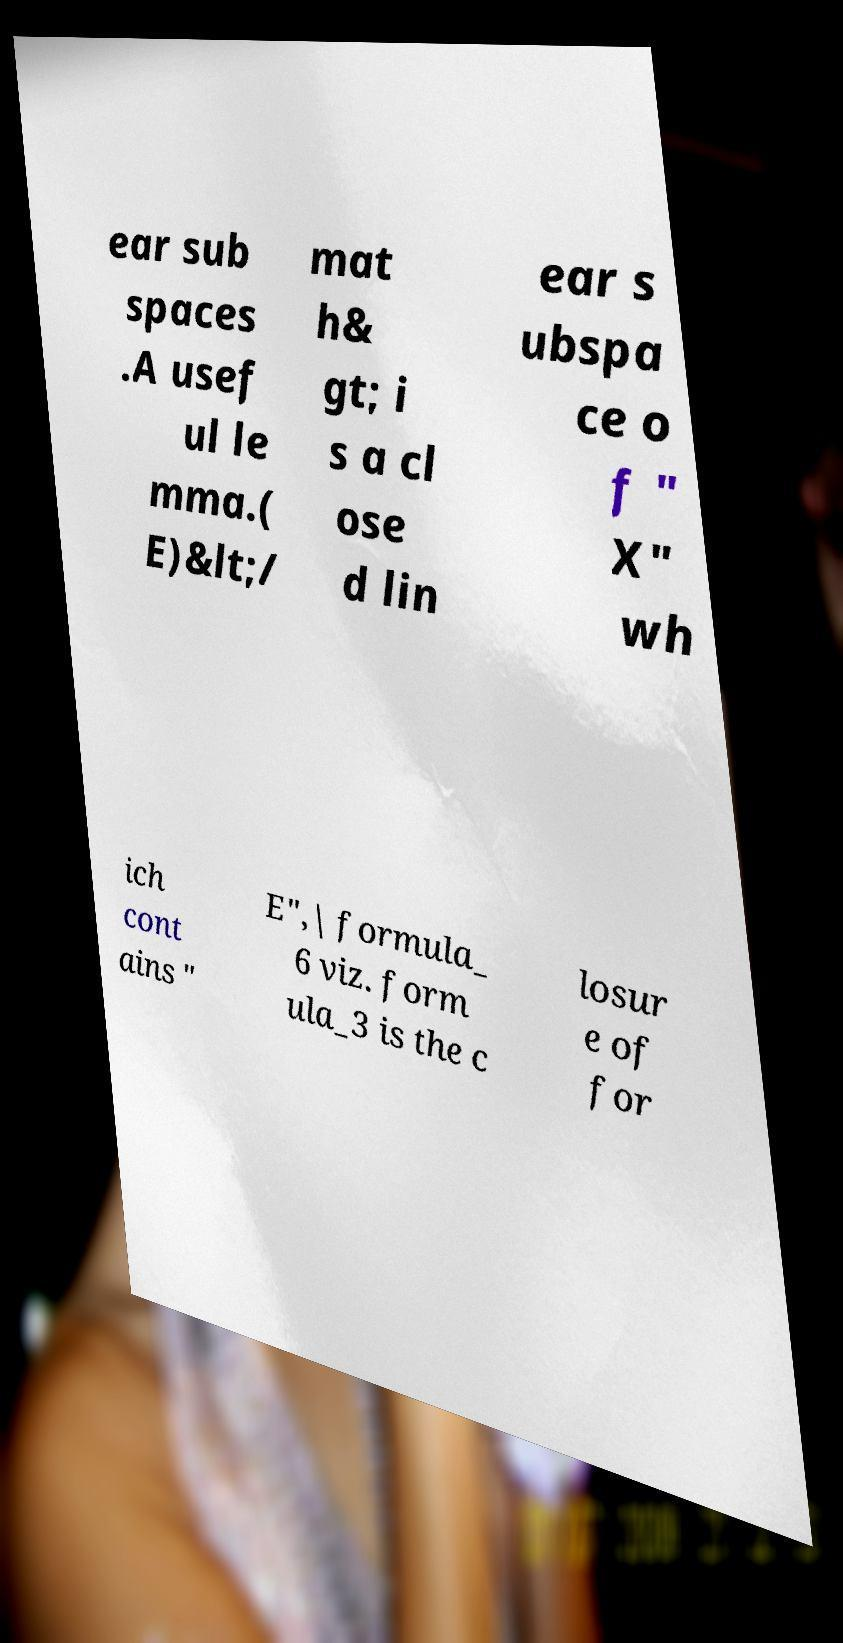Please identify and transcribe the text found in this image. ear sub spaces .A usef ul le mma.( E)&lt;/ mat h& gt; i s a cl ose d lin ear s ubspa ce o f " X" wh ich cont ains " E",| formula_ 6 viz. form ula_3 is the c losur e of for 